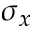<formula> <loc_0><loc_0><loc_500><loc_500>\sigma _ { x }</formula> 